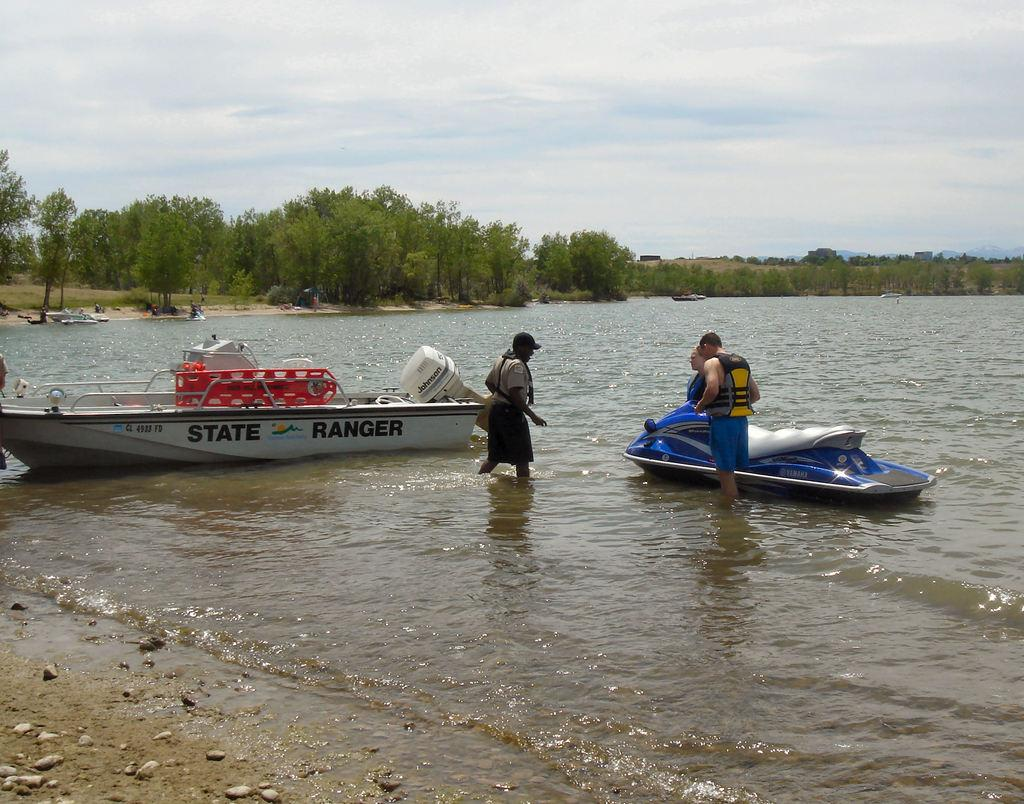What is present on the water in the image? There are boats on the water in the image. What are the people in the image doing? Three persons are standing in the water. What can be seen in the background of the image? There are trees and the sky visible in the background of the image. How many bikes are parked near the trees in the image? There are no bikes present in the image. What type of curtain is hanging from the boats in the image? There are no curtains hanging from the boats in the image; they are simply floating on the water. 